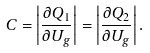Convert formula to latex. <formula><loc_0><loc_0><loc_500><loc_500>C = \left | \frac { \partial Q _ { 1 } } { \partial U _ { g } } \right | = \left | \frac { \partial Q _ { 2 } } { \partial U _ { g } } \right | .</formula> 